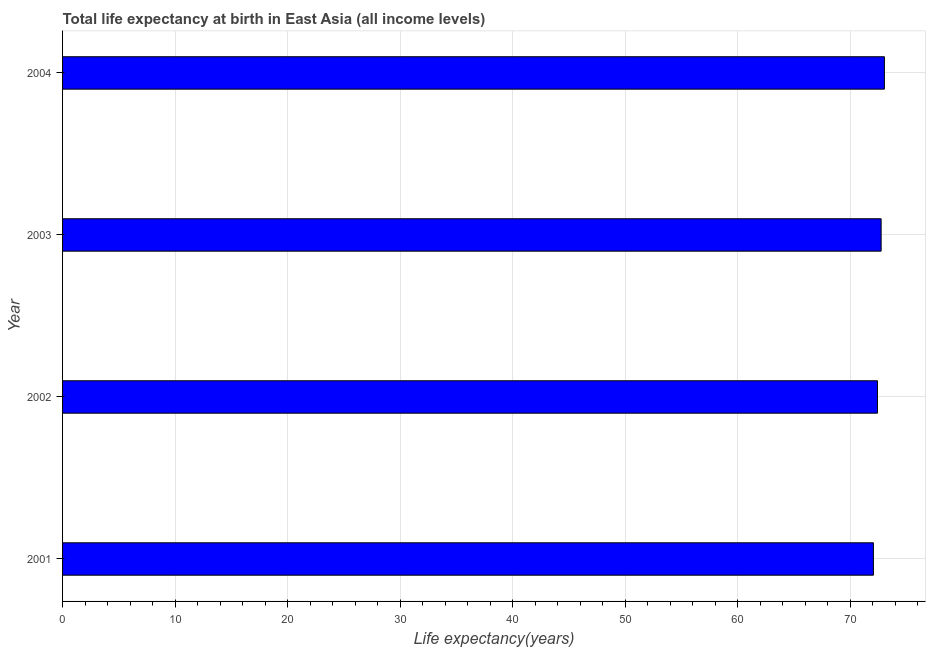Does the graph contain any zero values?
Offer a terse response. No. What is the title of the graph?
Your response must be concise. Total life expectancy at birth in East Asia (all income levels). What is the label or title of the X-axis?
Offer a terse response. Life expectancy(years). What is the life expectancy at birth in 2003?
Keep it short and to the point. 72.74. Across all years, what is the maximum life expectancy at birth?
Make the answer very short. 73.03. Across all years, what is the minimum life expectancy at birth?
Give a very brief answer. 72.06. In which year was the life expectancy at birth minimum?
Your answer should be very brief. 2001. What is the sum of the life expectancy at birth?
Offer a very short reply. 290.25. What is the difference between the life expectancy at birth in 2001 and 2004?
Your answer should be very brief. -0.98. What is the average life expectancy at birth per year?
Provide a short and direct response. 72.56. What is the median life expectancy at birth?
Your answer should be very brief. 72.58. What is the ratio of the life expectancy at birth in 2002 to that in 2004?
Your answer should be very brief. 0.99. What is the difference between the highest and the second highest life expectancy at birth?
Offer a very short reply. 0.29. In how many years, is the life expectancy at birth greater than the average life expectancy at birth taken over all years?
Provide a short and direct response. 2. How many bars are there?
Your answer should be compact. 4. Are all the bars in the graph horizontal?
Make the answer very short. Yes. How many years are there in the graph?
Offer a very short reply. 4. Are the values on the major ticks of X-axis written in scientific E-notation?
Provide a succinct answer. No. What is the Life expectancy(years) of 2001?
Your response must be concise. 72.06. What is the Life expectancy(years) in 2002?
Your answer should be compact. 72.42. What is the Life expectancy(years) in 2003?
Your response must be concise. 72.74. What is the Life expectancy(years) in 2004?
Your response must be concise. 73.03. What is the difference between the Life expectancy(years) in 2001 and 2002?
Give a very brief answer. -0.36. What is the difference between the Life expectancy(years) in 2001 and 2003?
Your answer should be compact. -0.69. What is the difference between the Life expectancy(years) in 2001 and 2004?
Ensure brevity in your answer.  -0.98. What is the difference between the Life expectancy(years) in 2002 and 2003?
Offer a terse response. -0.32. What is the difference between the Life expectancy(years) in 2002 and 2004?
Your response must be concise. -0.62. What is the difference between the Life expectancy(years) in 2003 and 2004?
Offer a very short reply. -0.29. What is the ratio of the Life expectancy(years) in 2002 to that in 2003?
Provide a short and direct response. 1. 